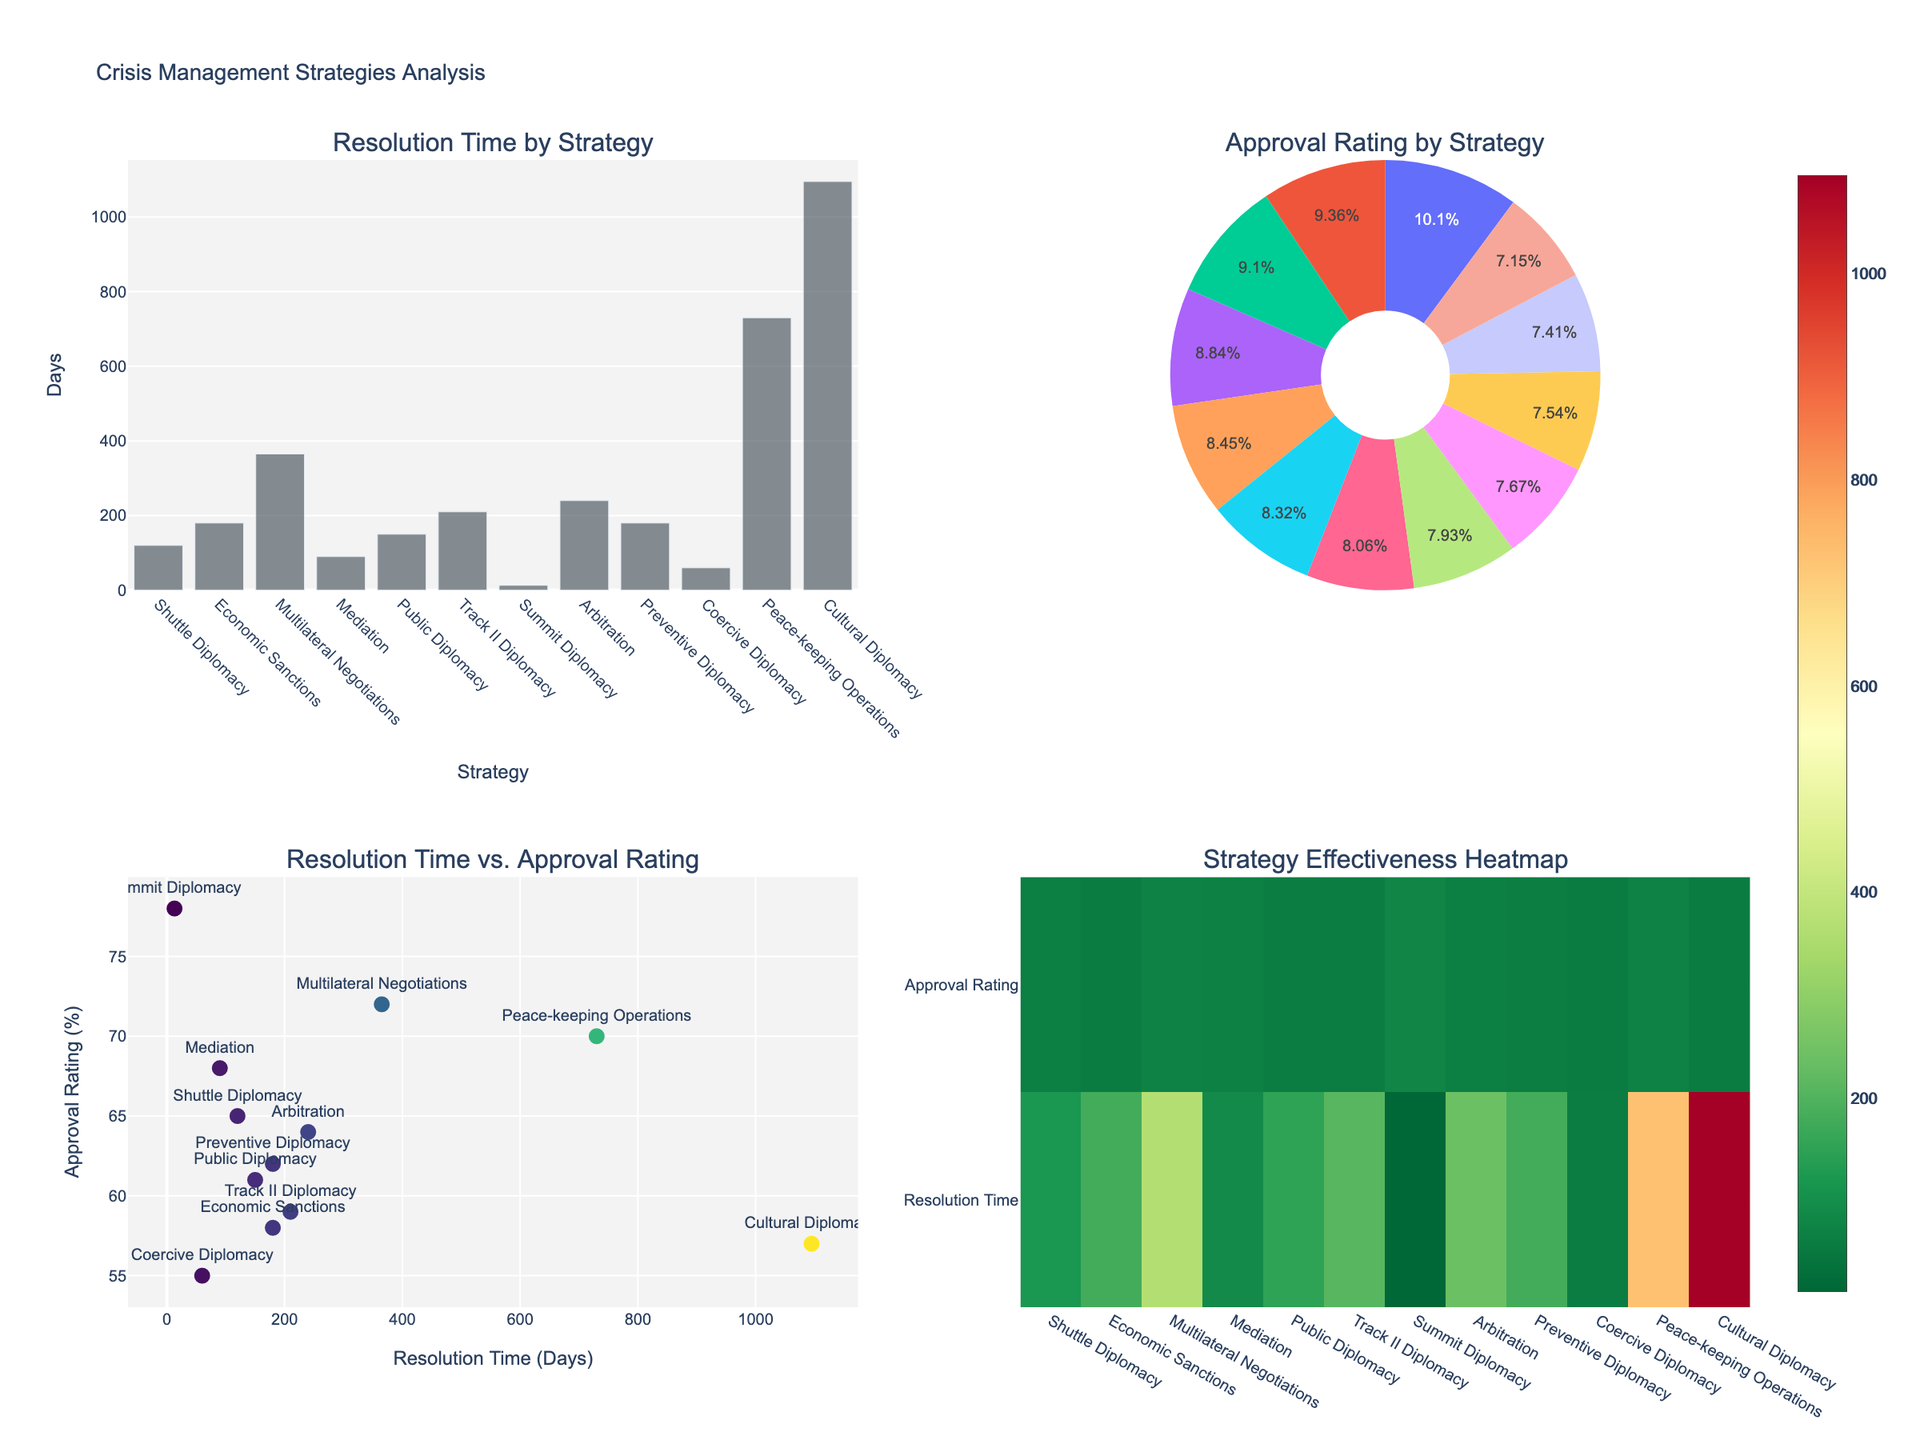What is the resolution time for the Cuban Missile Crisis? The resolution time is shown in the bar chart under "Resolution Time by Strategy." Locate the "Summit Diplomacy" bar and refer to the y-axis for the value.
Answer: 13 days Which strategy has the highest international approval rating in the pie chart? Check the "Approval Rating by Strategy" pie chart. Look for the largest segment which represents the highest approval rating.
Answer: Summit Diplomacy How does resolution time correlate with international approval rating in the scatter plot? In the scatter plot titled "Resolution Time vs. Approval Rating," observe the trend of points. Notice that shorter resolution times often align with higher approval ratings, but there are exceptions.
Answer: Shorter resolution times generally correlate with higher approval ratings What is the average resolution time across all strategies? Sum all the resolution times from the bar chart and divide by the total number of strategies (12). Calculate: (120 + 180 + 365 + 90 + 150 + 210 + 13 + 240 + 180 + 60 + 730 + 1095) / 12.
Answer: 273.08 days Comparing mediation and coercive diplomacy, which has a higher approval rating and by how much? From the bar chart, identify the approval ratings for "Mediation" and "Coercive Diplomacy." Then calculate the difference: 68% (Mediation) - 55% (Coercive Diplomacy).
Answer: Mediation by 13% Which subplot visually represents the overall effectiveness of each strategy in terms of both resolution time and approval rating? The heatmap provides a comprehensive visual of effectiveness by displaying combined metrics for both resolution time and approval rating.
Answer: The heatmap Which strategy required the longest resolution time and what is its approval rating? From the bar chart, identify the strategy with the longest bar. Refer to the corresponding approval rating in the pie chart or scatter plot. The strategy is "Cultural Diplomacy".
Answer: Cultural Diplomacy; 57% How many strategies have a resolution time greater than 200 days? Refer to the bar chart "Resolution Time by Strategy" and count the bars that extend beyond the 200-day mark.
Answer: 5 strategies In the scatter plot, which strategy has the very short resolution time of 13 days, and how does its approval rating compare to others? Locate the point at 13 days in the scatter plot. The strategy is "Summit Diplomacy," and it has one of the highest approval ratings at 78%.
Answer: Summit Diplomacy; high approval What is the color scale used in the scatter plot, and what does it represent? Observe the legend for the scatter plot. The color scale is "Viridis," and it indicates the range of resolution times with darker colors for shorter periods and lighter for longer.
Answer: Viridis; resolution times 